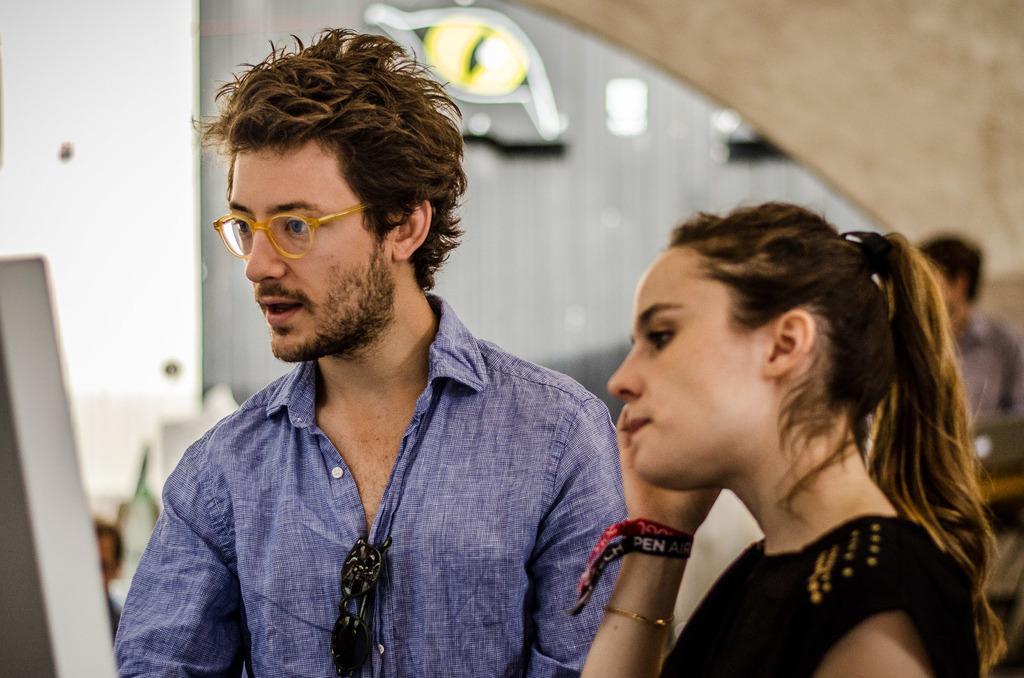Can you describe this image briefly? In this image we can see a man and a woman standing. In the background there are walls. 